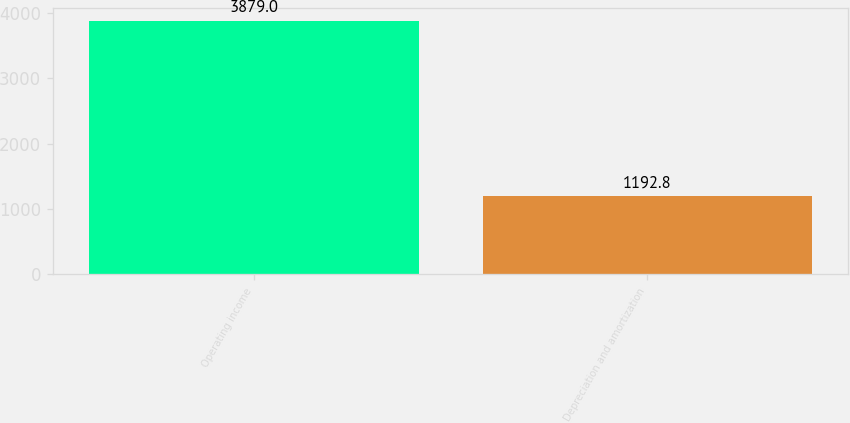Convert chart to OTSL. <chart><loc_0><loc_0><loc_500><loc_500><bar_chart><fcel>Operating income<fcel>Depreciation and amortization<nl><fcel>3879<fcel>1192.8<nl></chart> 